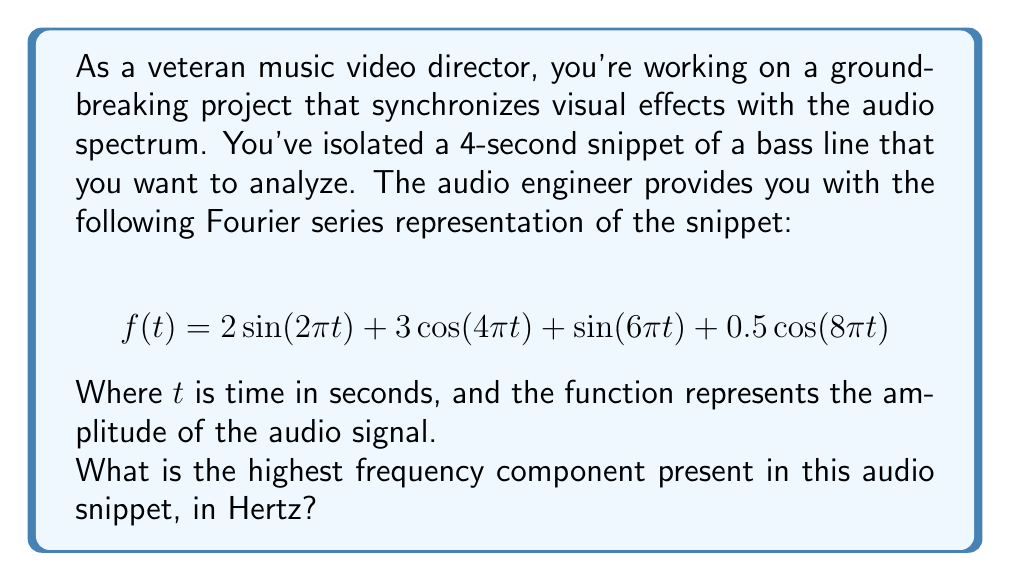Provide a solution to this math problem. Let's approach this step-by-step:

1) In a Fourier series, each term represents a frequency component of the signal. The general form for a sinusoidal component is:

   $$A \sin(2\pi ft) \text{ or } A \cos(2\pi ft)$$

   where $f$ is the frequency in Hertz, and $t$ is time in seconds.

2) In our given function:

   $$f(t) = 2\sin(2\pi t) + 3\cos(4\pi t) + \sin(6\pi t) + 0.5\cos(8\pi t)$$

3) Let's analyze each term:

   - $2\sin(2\pi t)$: Here, $2\pi f = 2\pi$, so $f = 1$ Hz
   - $3\cos(4\pi t)$: Here, $2\pi f = 4\pi$, so $f = 2$ Hz
   - $\sin(6\pi t)$: Here, $2\pi f = 6\pi$, so $f = 3$ Hz
   - $0.5\cos(8\pi t)$: Here, $2\pi f = 8\pi$, so $f = 4$ Hz

4) The highest frequency component is the one with the largest value of $f$, which is 4 Hz.
Answer: 4 Hz 